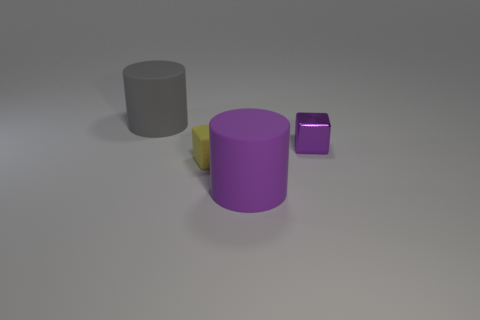Add 4 gray shiny balls. How many objects exist? 8 Subtract 2 cubes. How many cubes are left? 0 Subtract all yellow blocks. Subtract all gray cylinders. How many blocks are left? 1 Subtract all big purple things. Subtract all small purple shiny blocks. How many objects are left? 2 Add 2 big things. How many big things are left? 4 Add 4 rubber cubes. How many rubber cubes exist? 5 Subtract 0 green blocks. How many objects are left? 4 Subtract all cyan cylinders. How many yellow blocks are left? 1 